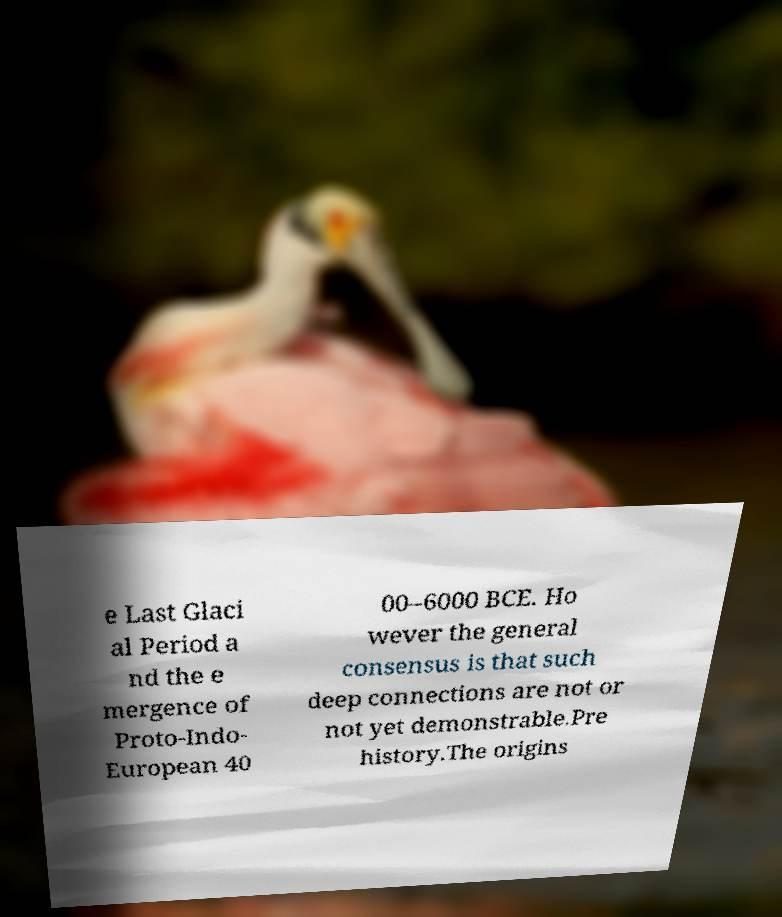I need the written content from this picture converted into text. Can you do that? e Last Glaci al Period a nd the e mergence of Proto-Indo- European 40 00–6000 BCE. Ho wever the general consensus is that such deep connections are not or not yet demonstrable.Pre history.The origins 